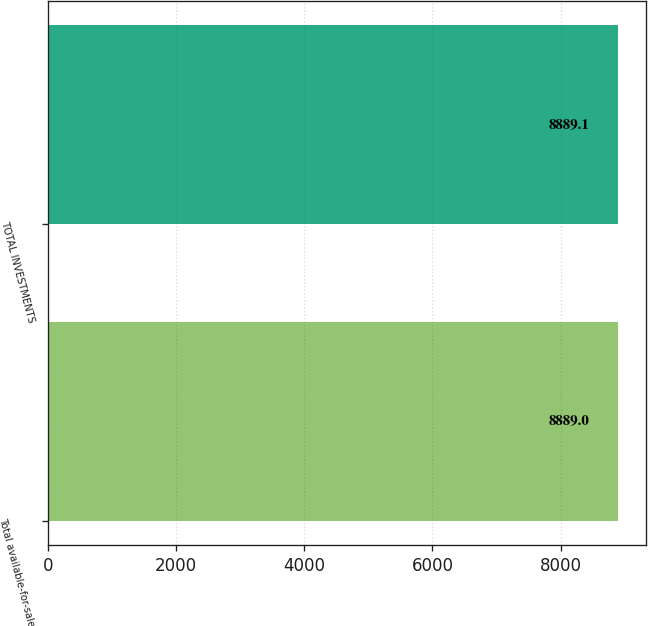<chart> <loc_0><loc_0><loc_500><loc_500><bar_chart><fcel>Total available-for-sale<fcel>TOTAL INVESTMENTS<nl><fcel>8889<fcel>8889.1<nl></chart> 